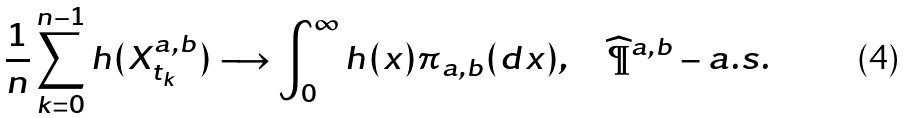Convert formula to latex. <formula><loc_0><loc_0><loc_500><loc_500>\frac { 1 } { n } \sum _ { k = 0 } ^ { n - 1 } h ( X _ { t _ { k } } ^ { a , b } ) \longrightarrow \int _ { 0 } ^ { \infty } h ( x ) \pi _ { a , b } ( d x ) , \quad \widehat { \P } ^ { a , b } - a . s .</formula> 